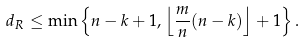Convert formula to latex. <formula><loc_0><loc_0><loc_500><loc_500>d _ { R } \leq \min \left \{ n - k + 1 , \left \lfloor \frac { m } { n } ( n - k ) \right \rfloor + 1 \right \} .</formula> 